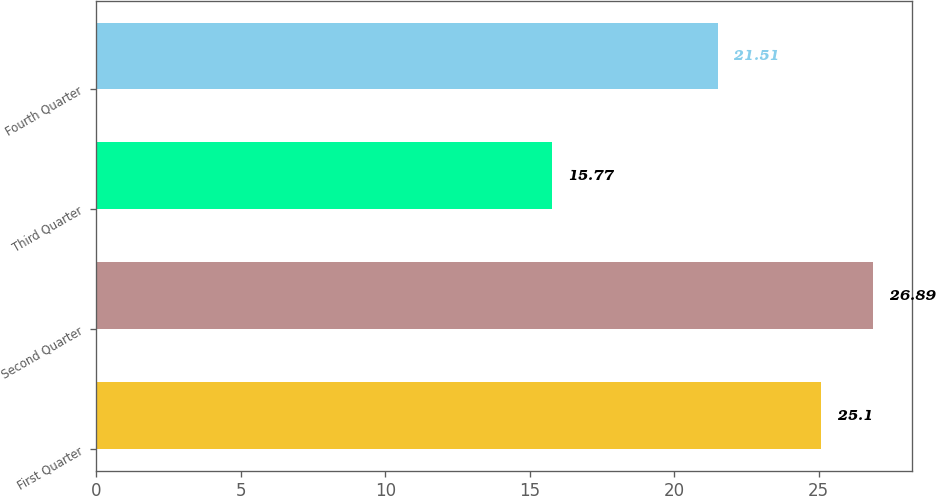Convert chart to OTSL. <chart><loc_0><loc_0><loc_500><loc_500><bar_chart><fcel>First Quarter<fcel>Second Quarter<fcel>Third Quarter<fcel>Fourth Quarter<nl><fcel>25.1<fcel>26.89<fcel>15.77<fcel>21.51<nl></chart> 